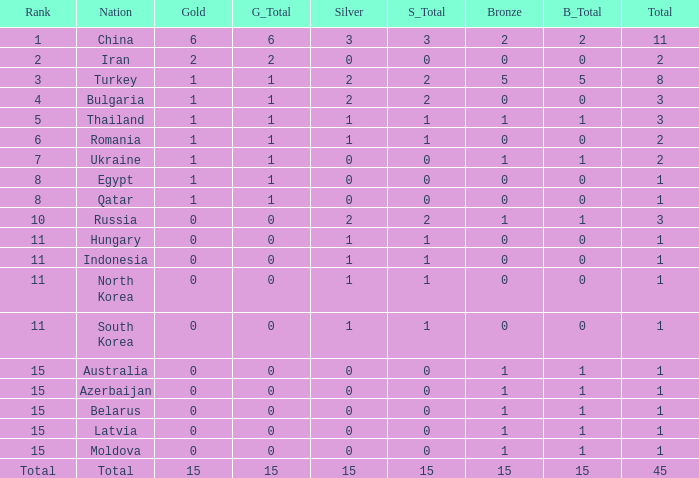Wha is the average number of bronze of hungary, which has less than 1 silver? None. 